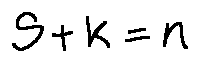<formula> <loc_0><loc_0><loc_500><loc_500>S + k = n</formula> 